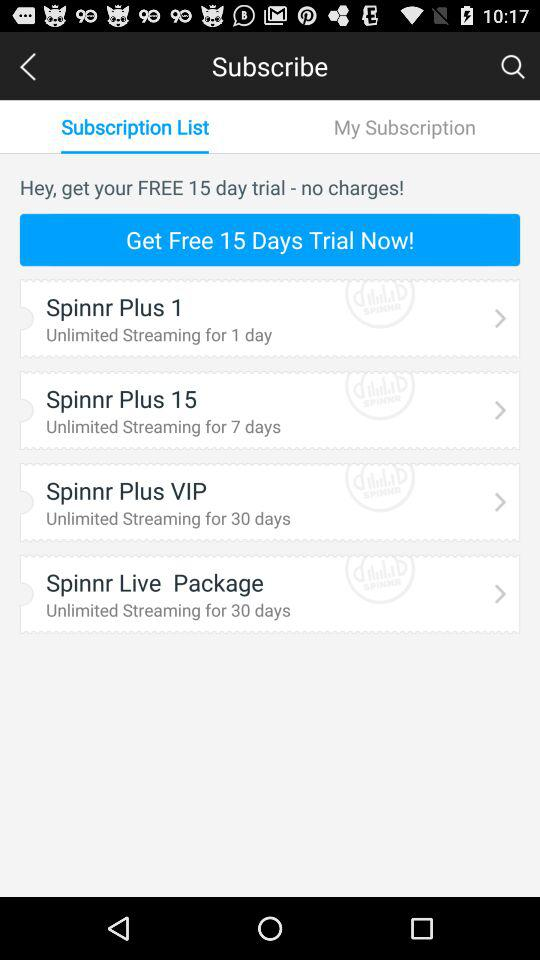Are there any charges applicable for the free trial? There are no charges applicable for the free trial. 